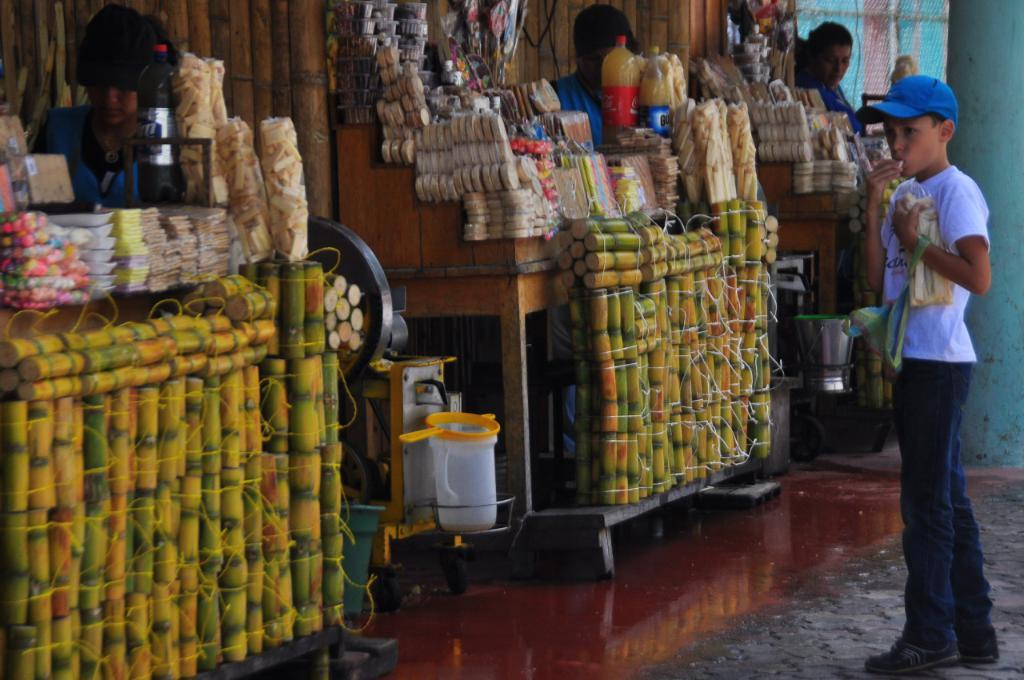How many people are in the image? There are people in the image, but the exact number cannot be determined from the provided facts. Can you describe the boy in the image? The boy in the image is wearing a cap. What is the boy holding in his hands? The boy is holding objects in his hands, but the specific objects cannot be determined from the provided facts. What type of container is present in the image? There is a jug in the image. What other type of container is present in the image? There is a bucket in the image. What type of items are present in the image? There are bottles and food items in the image. What other objects are present in the image? There are other objects in the image, but their specific nature cannot be determined from the provided facts. How far away is the house from the people in the image? There is no house present in the image, so it is not possible to determine the distance between the people and a house. 